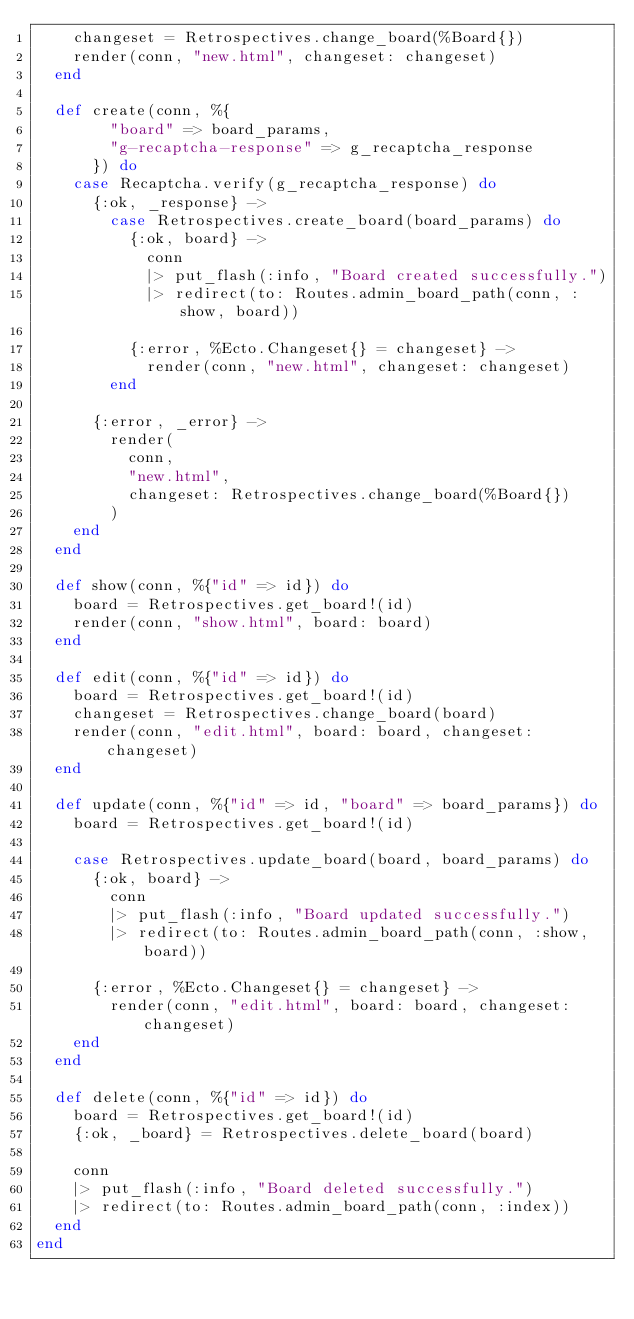<code> <loc_0><loc_0><loc_500><loc_500><_Elixir_>    changeset = Retrospectives.change_board(%Board{})
    render(conn, "new.html", changeset: changeset)
  end

  def create(conn, %{
        "board" => board_params,
        "g-recaptcha-response" => g_recaptcha_response
      }) do
    case Recaptcha.verify(g_recaptcha_response) do
      {:ok, _response} ->
        case Retrospectives.create_board(board_params) do
          {:ok, board} ->
            conn
            |> put_flash(:info, "Board created successfully.")
            |> redirect(to: Routes.admin_board_path(conn, :show, board))

          {:error, %Ecto.Changeset{} = changeset} ->
            render(conn, "new.html", changeset: changeset)
        end

      {:error, _error} ->
        render(
          conn,
          "new.html",
          changeset: Retrospectives.change_board(%Board{})
        )
    end
  end

  def show(conn, %{"id" => id}) do
    board = Retrospectives.get_board!(id)
    render(conn, "show.html", board: board)
  end

  def edit(conn, %{"id" => id}) do
    board = Retrospectives.get_board!(id)
    changeset = Retrospectives.change_board(board)
    render(conn, "edit.html", board: board, changeset: changeset)
  end

  def update(conn, %{"id" => id, "board" => board_params}) do
    board = Retrospectives.get_board!(id)

    case Retrospectives.update_board(board, board_params) do
      {:ok, board} ->
        conn
        |> put_flash(:info, "Board updated successfully.")
        |> redirect(to: Routes.admin_board_path(conn, :show, board))

      {:error, %Ecto.Changeset{} = changeset} ->
        render(conn, "edit.html", board: board, changeset: changeset)
    end
  end

  def delete(conn, %{"id" => id}) do
    board = Retrospectives.get_board!(id)
    {:ok, _board} = Retrospectives.delete_board(board)

    conn
    |> put_flash(:info, "Board deleted successfully.")
    |> redirect(to: Routes.admin_board_path(conn, :index))
  end
end
</code> 